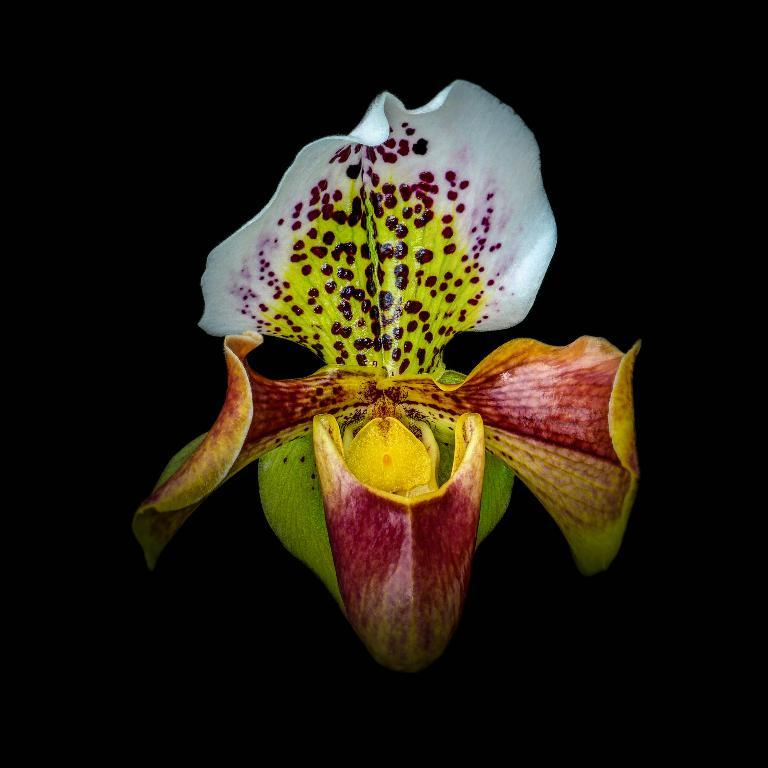What is the main subject of the image? There is a flower in the center of the image. Can you describe the colors of the flower? The flower has red, white, yellow, and green colors. What type of store can be seen in the background of the image? There is no store present in the image; it only features a flower. Can you describe the design of the ant crawling on the flower in the image? There is no ant present in the image; it only features a flower with red, white, yellow, and green colors. 